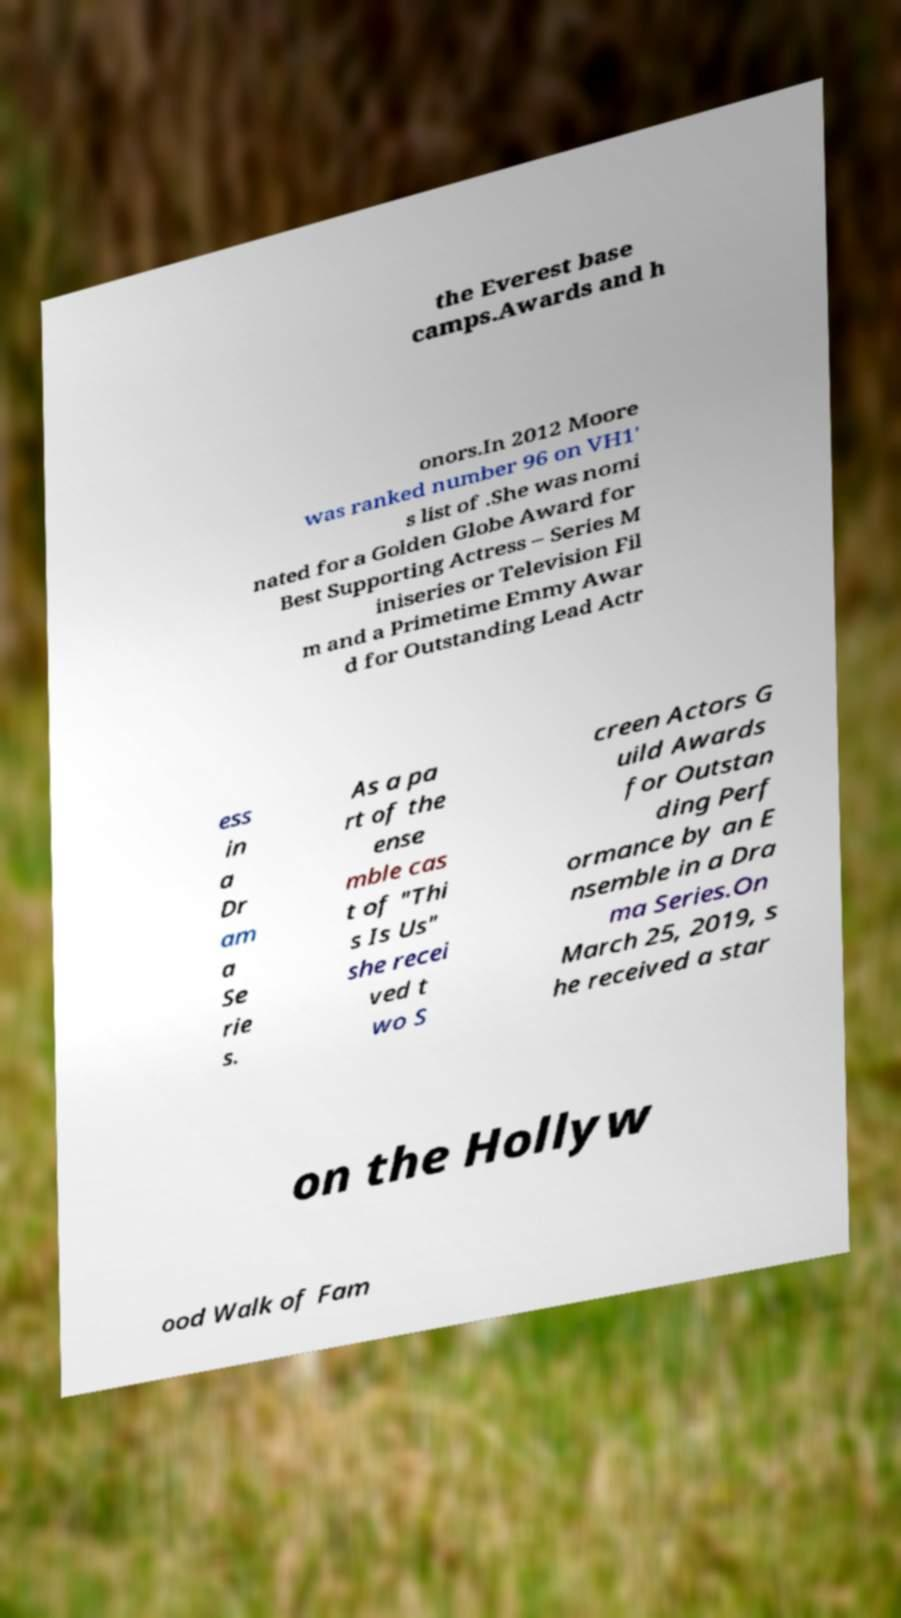Could you extract and type out the text from this image? the Everest base camps.Awards and h onors.In 2012 Moore was ranked number 96 on VH1' s list of .She was nomi nated for a Golden Globe Award for Best Supporting Actress – Series M iniseries or Television Fil m and a Primetime Emmy Awar d for Outstanding Lead Actr ess in a Dr am a Se rie s. As a pa rt of the ense mble cas t of "Thi s Is Us" she recei ved t wo S creen Actors G uild Awards for Outstan ding Perf ormance by an E nsemble in a Dra ma Series.On March 25, 2019, s he received a star on the Hollyw ood Walk of Fam 